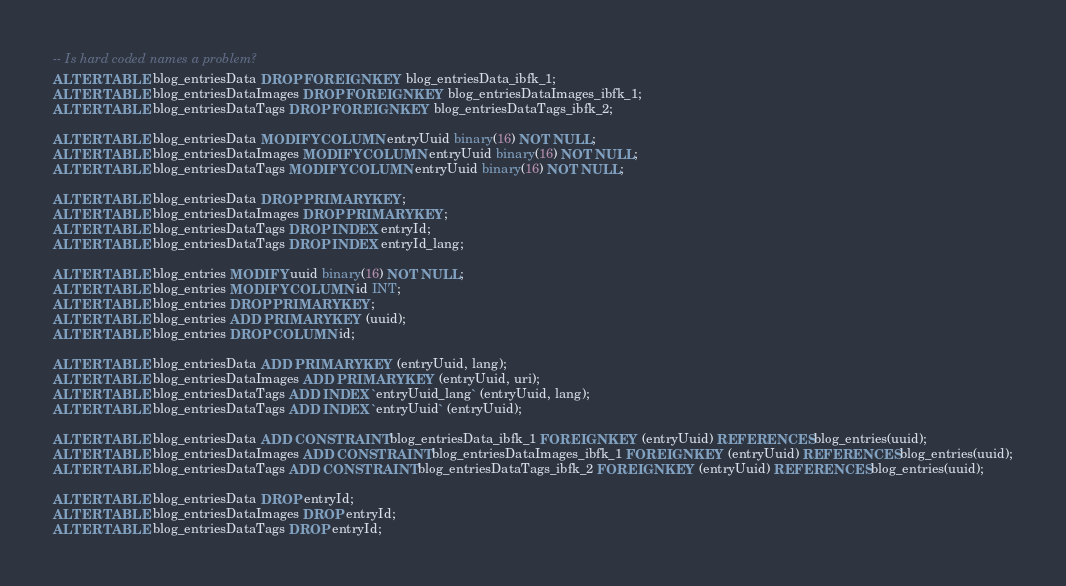<code> <loc_0><loc_0><loc_500><loc_500><_SQL_>
-- Is hard coded names a problem?
ALTER TABLE blog_entriesData DROP FOREIGN KEY blog_entriesData_ibfk_1;
ALTER TABLE blog_entriesDataImages DROP FOREIGN KEY blog_entriesDataImages_ibfk_1;
ALTER TABLE blog_entriesDataTags DROP FOREIGN KEY blog_entriesDataTags_ibfk_2;

ALTER TABLE blog_entriesData MODIFY COLUMN entryUuid binary(16) NOT NULL;
ALTER TABLE blog_entriesDataImages MODIFY COLUMN entryUuid binary(16) NOT NULL;
ALTER TABLE blog_entriesDataTags MODIFY COLUMN entryUuid binary(16) NOT NULL;

ALTER TABLE blog_entriesData DROP PRIMARY KEY;
ALTER TABLE blog_entriesDataImages DROP PRIMARY KEY;
ALTER TABLE blog_entriesDataTags DROP INDEX entryId;
ALTER TABLE blog_entriesDataTags DROP INDEX entryId_lang;

ALTER TABLE blog_entries MODIFY uuid binary(16) NOT NULL;
ALTER TABLE blog_entries MODIFY COLUMN id INT;
ALTER TABLE blog_entries DROP PRIMARY KEY;
ALTER TABLE blog_entries ADD PRIMARY KEY (uuid);
ALTER TABLE blog_entries DROP COLUMN id;

ALTER TABLE blog_entriesData ADD PRIMARY KEY (entryUuid, lang);
ALTER TABLE blog_entriesDataImages ADD PRIMARY KEY (entryUuid, uri);
ALTER TABLE blog_entriesDataTags ADD INDEX `entryUuid_lang` (entryUuid, lang);
ALTER TABLE blog_entriesDataTags ADD INDEX `entryUuid` (entryUuid);

ALTER TABLE blog_entriesData ADD CONSTRAINT blog_entriesData_ibfk_1 FOREIGN KEY (entryUuid) REFERENCES blog_entries(uuid);
ALTER TABLE blog_entriesDataImages ADD CONSTRAINT blog_entriesDataImages_ibfk_1 FOREIGN KEY (entryUuid) REFERENCES blog_entries(uuid);
ALTER TABLE blog_entriesDataTags ADD CONSTRAINT blog_entriesDataTags_ibfk_2 FOREIGN KEY (entryUuid) REFERENCES blog_entries(uuid);

ALTER TABLE blog_entriesData DROP entryId;
ALTER TABLE blog_entriesDataImages DROP entryId;
ALTER TABLE blog_entriesDataTags DROP entryId;
</code> 